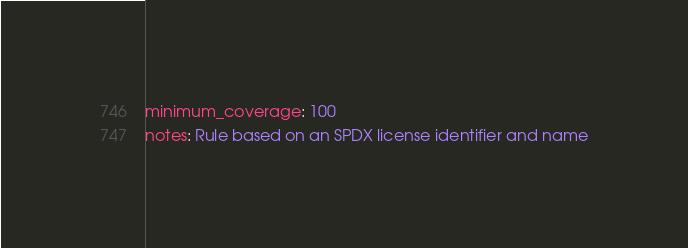<code> <loc_0><loc_0><loc_500><loc_500><_YAML_>minimum_coverage: 100
notes: Rule based on an SPDX license identifier and name
</code> 